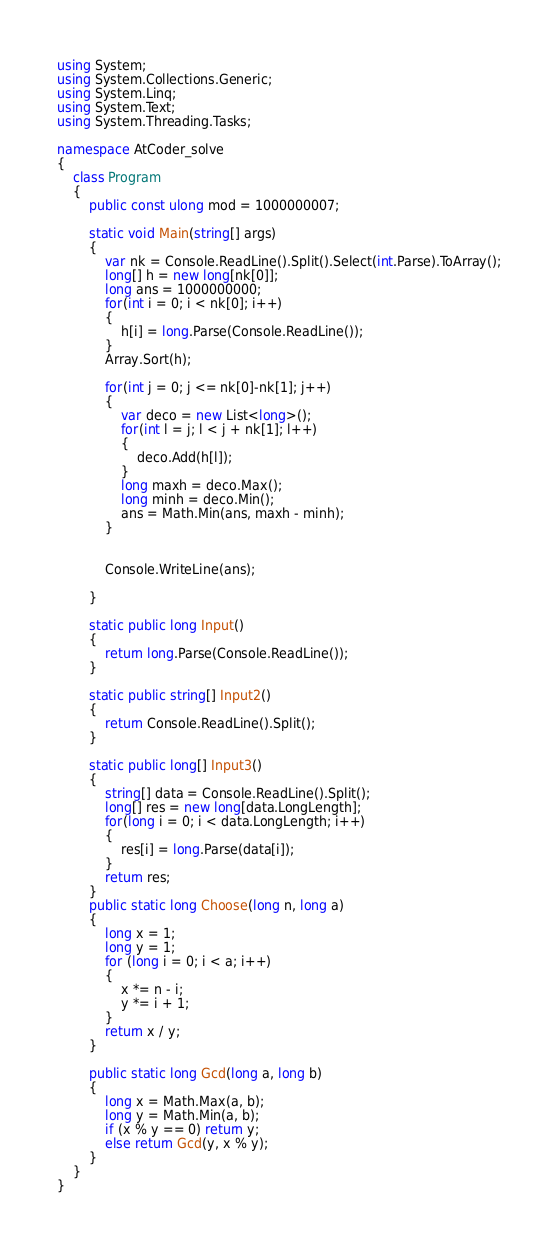Convert code to text. <code><loc_0><loc_0><loc_500><loc_500><_C#_>using System;
using System.Collections.Generic;
using System.Linq;
using System.Text;
using System.Threading.Tasks;

namespace AtCoder_solve
{
    class Program
    {
        public const ulong mod = 1000000007;

        static void Main(string[] args)
        {
            var nk = Console.ReadLine().Split().Select(int.Parse).ToArray();
            long[] h = new long[nk[0]];
            long ans = 1000000000;
            for(int i = 0; i < nk[0]; i++)
            {
                h[i] = long.Parse(Console.ReadLine());
            }
            Array.Sort(h);

            for(int j = 0; j <= nk[0]-nk[1]; j++)
            {
                var deco = new List<long>();
                for(int l = j; l < j + nk[1]; l++)
                {
                    deco.Add(h[l]);
                }
                long maxh = deco.Max();
                long minh = deco.Min();
                ans = Math.Min(ans, maxh - minh);
            }
           
            
            Console.WriteLine(ans);
            
        }

        static public long Input()
        {
            return long.Parse(Console.ReadLine());
        }

        static public string[] Input2()
        {
            return Console.ReadLine().Split();
        }
        
        static public long[] Input3()
        {
            string[] data = Console.ReadLine().Split();
            long[] res = new long[data.LongLength];
            for(long i = 0; i < data.LongLength; i++)
            {
                res[i] = long.Parse(data[i]);
            }
            return res;
        }
        public static long Choose(long n, long a)
        {
            long x = 1;
            long y = 1;
            for (long i = 0; i < a; i++)
            {
                x *= n - i;
                y *= i + 1;
            }
            return x / y;
        }

        public static long Gcd(long a, long b)
        {
            long x = Math.Max(a, b);
            long y = Math.Min(a, b);
            if (x % y == 0) return y;
            else return Gcd(y, x % y);
        }
    }
}
</code> 